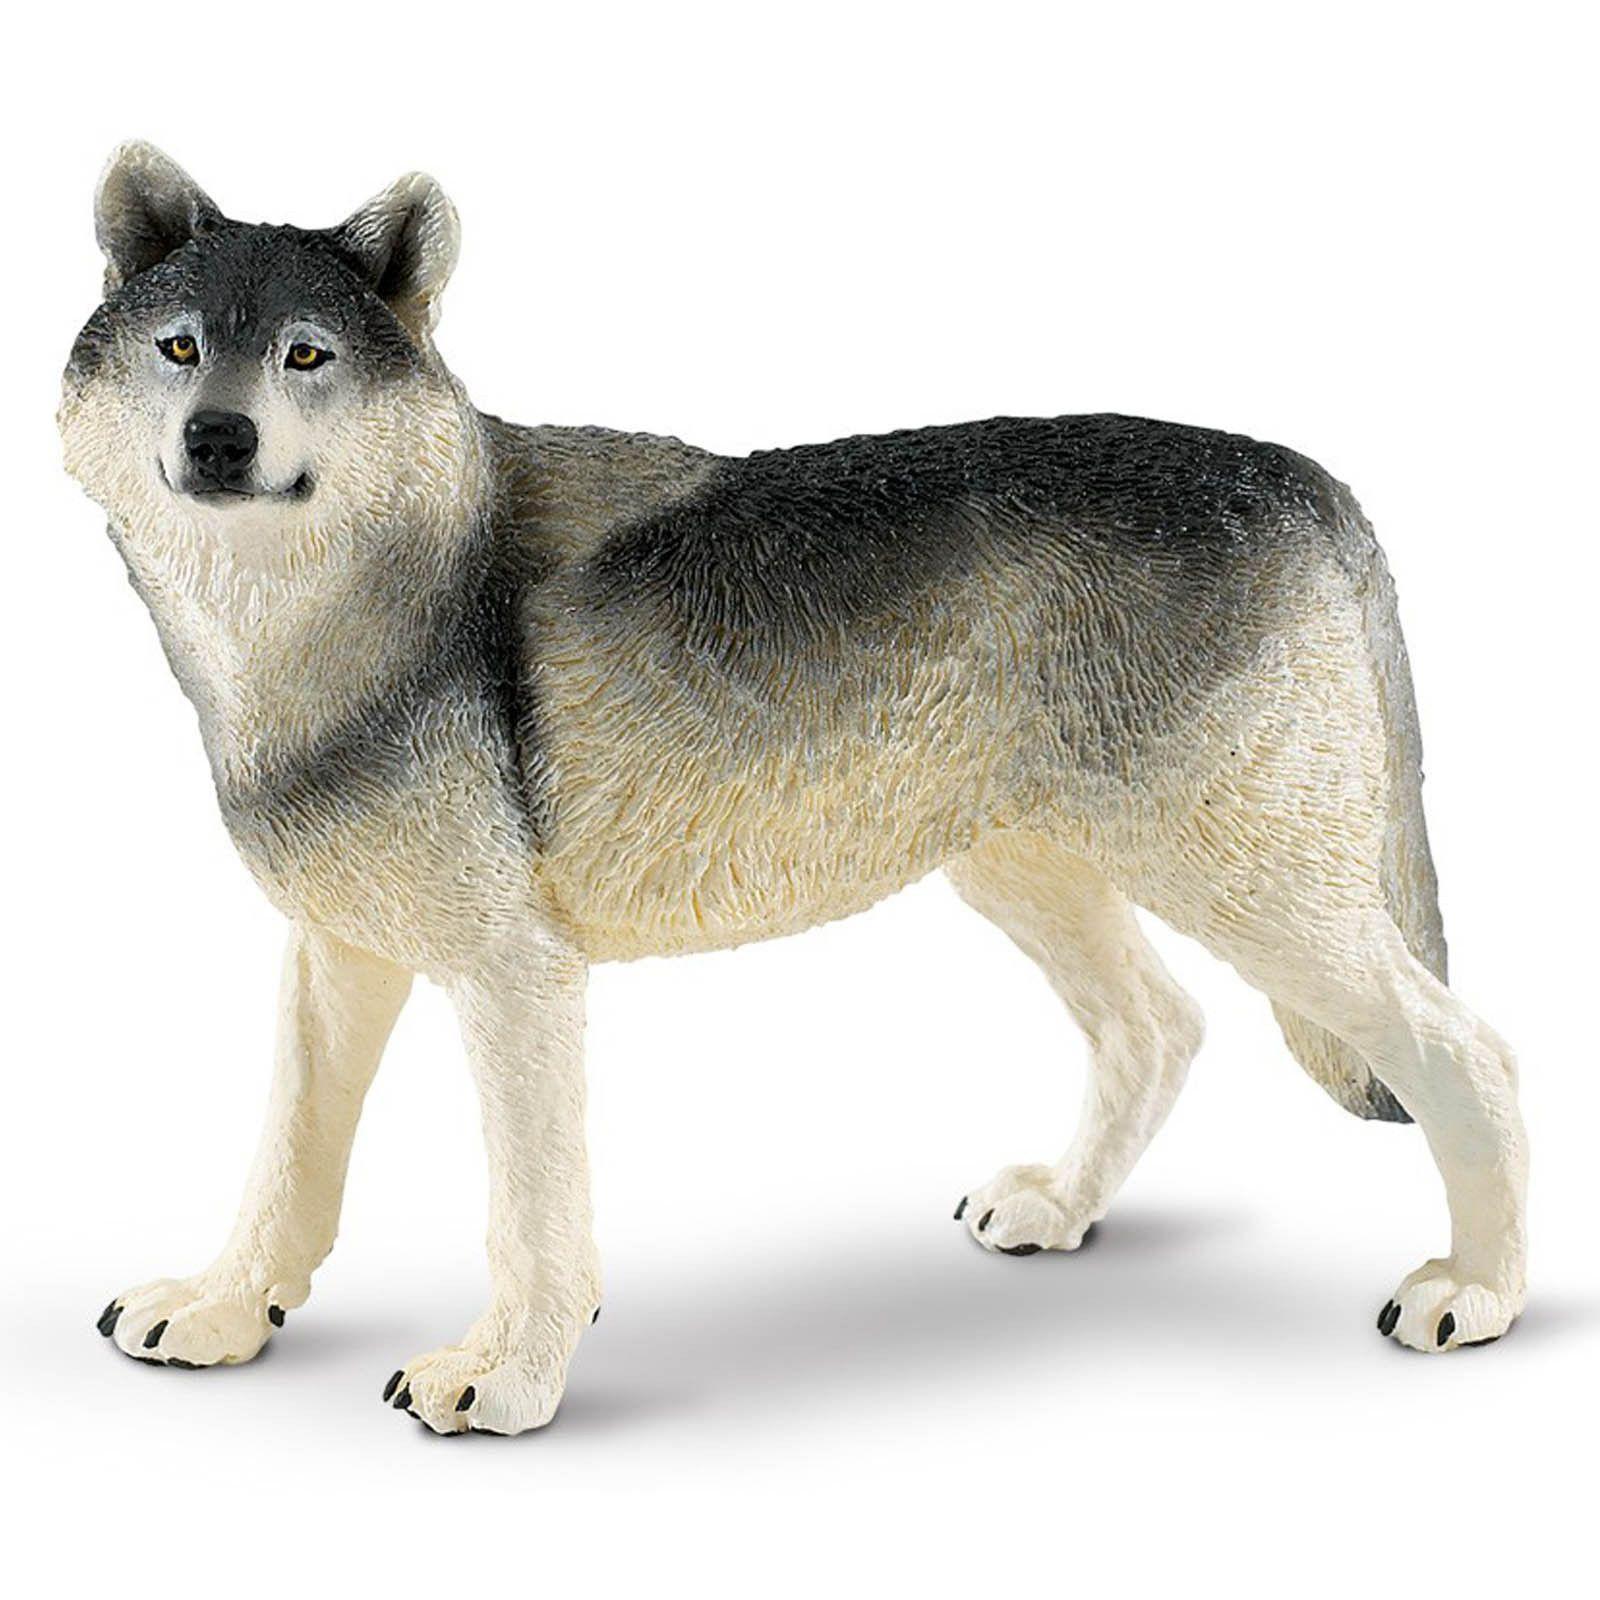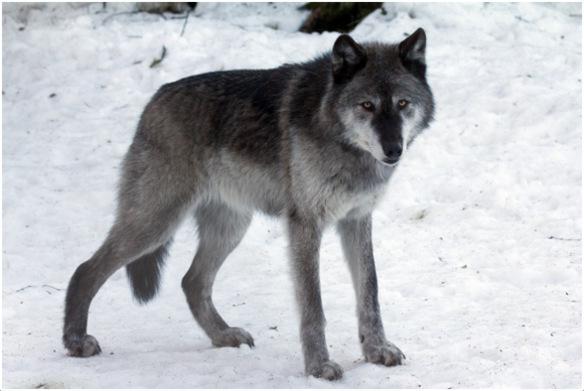The first image is the image on the left, the second image is the image on the right. Considering the images on both sides, is "One image shows a howling wolf with raised head." valid? Answer yes or no. No. 